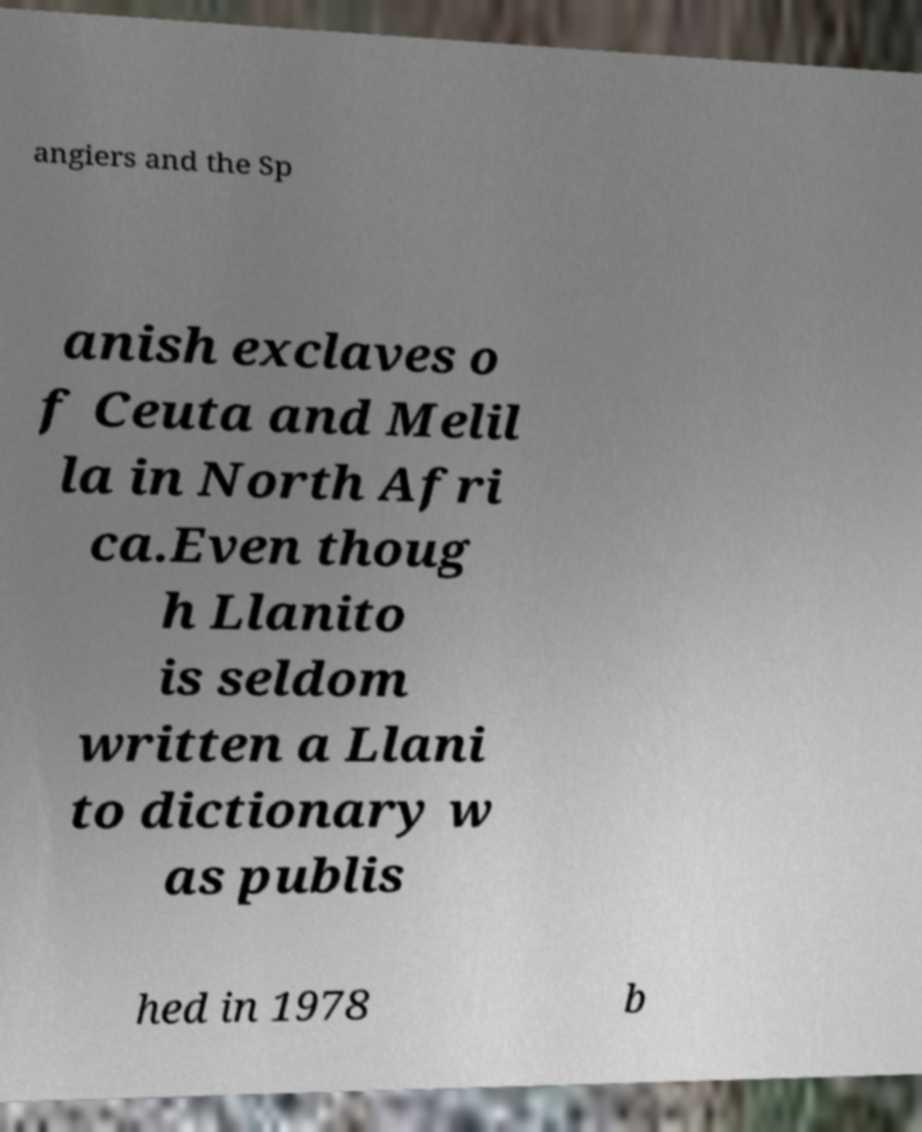Please read and relay the text visible in this image. What does it say? angiers and the Sp anish exclaves o f Ceuta and Melil la in North Afri ca.Even thoug h Llanito is seldom written a Llani to dictionary w as publis hed in 1978 b 